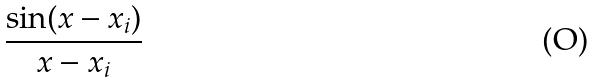<formula> <loc_0><loc_0><loc_500><loc_500>\frac { \sin ( x - x _ { i } ) } { x - x _ { i } }</formula> 